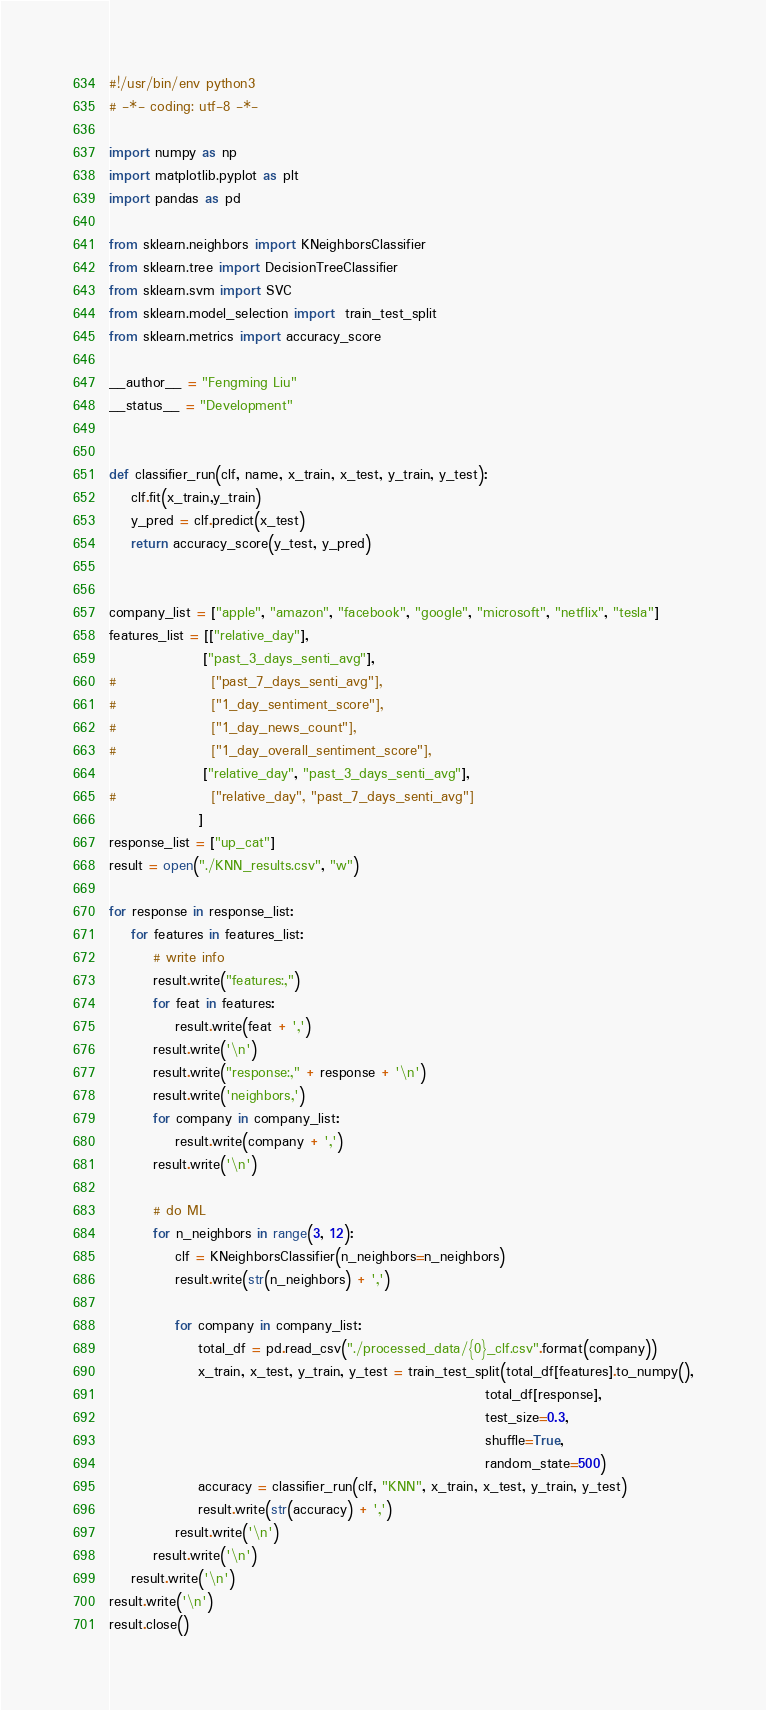Convert code to text. <code><loc_0><loc_0><loc_500><loc_500><_Python_>#!/usr/bin/env python3
# -*- coding: utf-8 -*-

import numpy as np
import matplotlib.pyplot as plt
import pandas as pd

from sklearn.neighbors import KNeighborsClassifier
from sklearn.tree import DecisionTreeClassifier
from sklearn.svm import SVC
from sklearn.model_selection import  train_test_split
from sklearn.metrics import accuracy_score

__author__ = "Fengming Liu"
__status__ = "Development"

    
def classifier_run(clf, name, x_train, x_test, y_train, y_test):
    clf.fit(x_train,y_train)
    y_pred = clf.predict(x_test)
    return accuracy_score(y_test, y_pred)


company_list = ["apple", "amazon", "facebook", "google", "microsoft", "netflix", "tesla"]
features_list = [["relative_day"],
                 ["past_3_days_senti_avg"],
#                 ["past_7_days_senti_avg"],
#                 ["1_day_sentiment_score"],
#                 ["1_day_news_count"],
#                 ["1_day_overall_sentiment_score"],
                 ["relative_day", "past_3_days_senti_avg"],
#                 ["relative_day", "past_7_days_senti_avg"]
                ]
response_list = ["up_cat"]
result = open("./KNN_results.csv", "w")

for response in response_list:
    for features in features_list:
        # write info
        result.write("features:,")
        for feat in features:
            result.write(feat + ',')
        result.write('\n')
        result.write("response:," + response + '\n')
        result.write('neighbors,')
        for company in company_list:
            result.write(company + ',')
        result.write('\n')
        
        # do ML
        for n_neighbors in range(3, 12):
            clf = KNeighborsClassifier(n_neighbors=n_neighbors)
            result.write(str(n_neighbors) + ',')
    
            for company in company_list:
                total_df = pd.read_csv("./processed_data/{0}_clf.csv".format(company))
                x_train, x_test, y_train, y_test = train_test_split(total_df[features].to_numpy(),
                                                                    total_df[response],
                                                                    test_size=0.3,
                                                                    shuffle=True,
                                                                    random_state=500)
                accuracy = classifier_run(clf, "KNN", x_train, x_test, y_train, y_test)
                result.write(str(accuracy) + ',')
            result.write('\n')
        result.write('\n')
    result.write('\n')
result.write('\n')
result.close()
</code> 